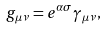<formula> <loc_0><loc_0><loc_500><loc_500>g _ { \mu \nu } = e ^ { \alpha \sigma } \gamma _ { \mu \nu } ,</formula> 